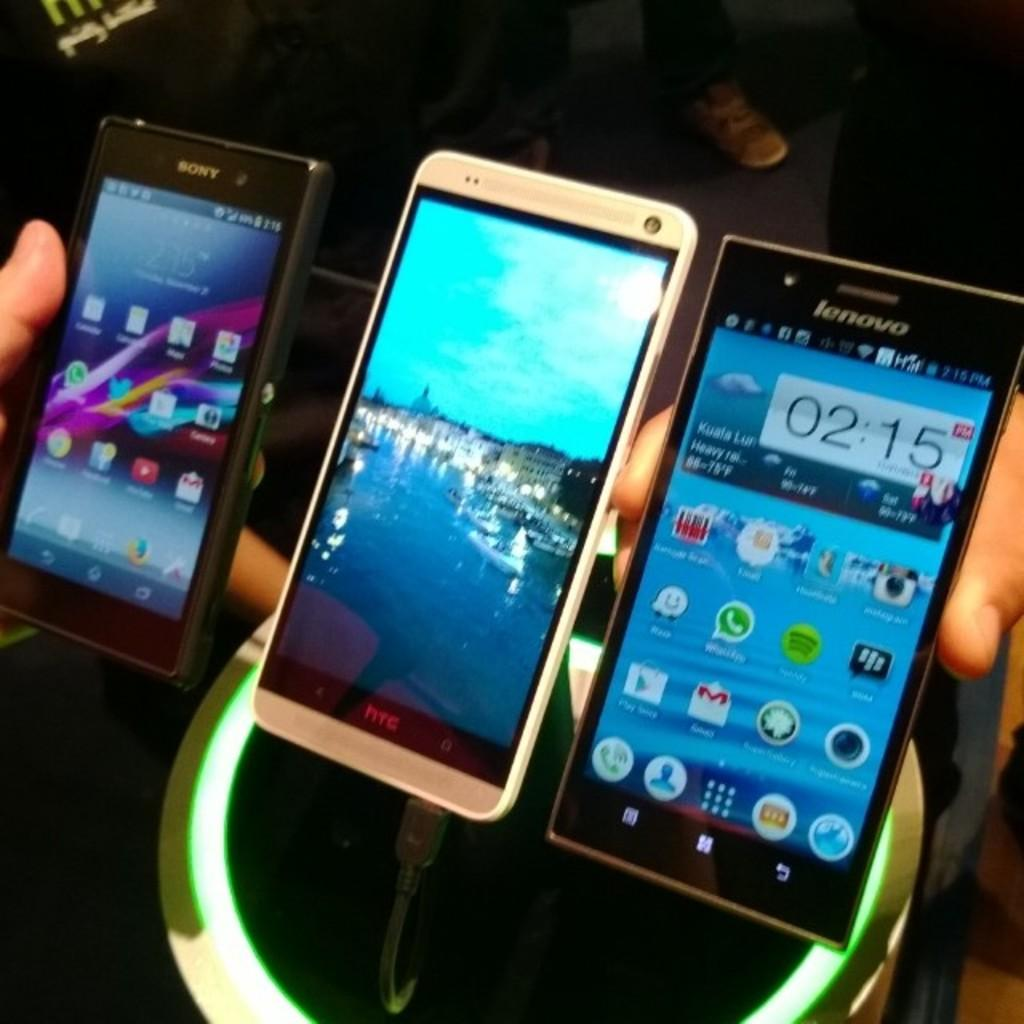<image>
Present a compact description of the photo's key features. Three mobile phones lined up in hands, with the closest one being lenovo and the middle htc charging. 